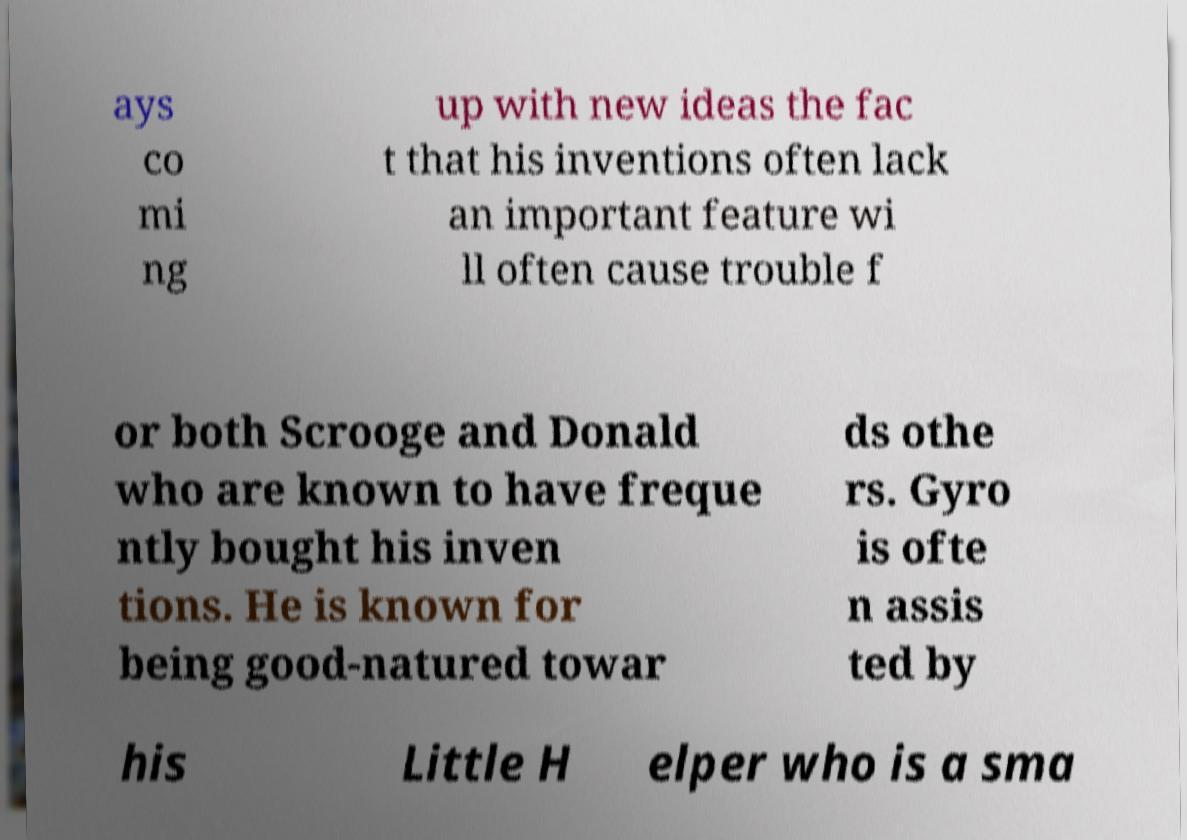Could you extract and type out the text from this image? ays co mi ng up with new ideas the fac t that his inventions often lack an important feature wi ll often cause trouble f or both Scrooge and Donald who are known to have freque ntly bought his inven tions. He is known for being good-natured towar ds othe rs. Gyro is ofte n assis ted by his Little H elper who is a sma 